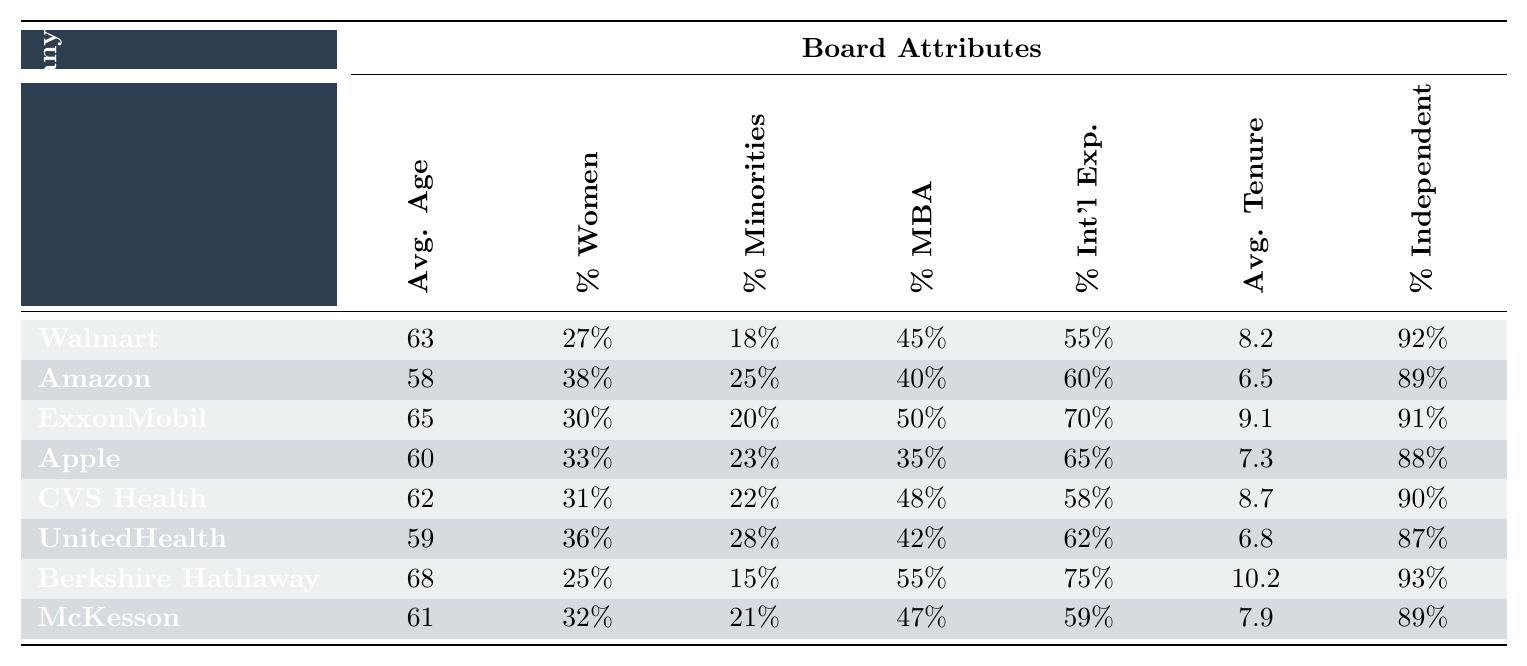What is the average age of the board members of Amazon? The table shows that the average age of Amazon board members is listed under the "Avg. Age" column as 58.
Answer: 58 Which company has the highest percentage of women on its board? By comparing the "% Women" values in the table, we can see that Amazon has the highest percentage at 38%.
Answer: 38% What is the average tenure of board members at Berkshire Hathaway? The average tenure is shown in the "Avg. Tenure" column for Berkshire Hathaway, which is 10.2 years.
Answer: 10.2 Is it true that CVS Health has more independent directors than McKesson? Looking at the "% Independent" column, CVS Health has 90% independent directors, while McKesson has 89%, indicating that CVS Health has more.
Answer: Yes What is the difference in average age between ExxonMobil and Walmart board members? The average age for ExxonMobil is 65, and for Walmart it is 63, so the difference is 65 - 63 = 2 years.
Answer: 2 If we sum the percentages of women across all companies, what is the total? The percentages of women are: 27 + 38 + 30 + 33 + 31 + 36 + 25 + 32 = 252%. Then, the total is 252%.
Answer: 252% What percentage of board members across all companies have international experience? By summing the percentages for "% Int'l Exp.": 55 + 60 + 70 + 65 + 58 + 62 + 75 + 59 =  474%. To find the average percentage of international experience, divide by the number of companies (8): 474 / 8 = 59.25%.
Answer: 59.25% Which company has the lowest percentage of racial/ethnic minorities on its board? By comparing the "% Minorities" column, we find that Berkshire Hathaway has the lowest percentage at 15%.
Answer: 15% What is the average age of the board members for companies with more than 30% women? The companies with more than 30% women are Amazon (58), ExxonMobil (65), Apple (60), and UnitedHealth (59). The average age = (58 + 65 + 60 + 59) / 4 = 60.5 years.
Answer: 60.5 Are there more board members with an MBA at ExxonMobil compared to CVS Health? Looking at the "% MBA" column, ExxonMobil has 50% and CVS Health has 48%, indicating that ExxonMobil has more board members with an MBA.
Answer: Yes What is the average tenure of board members in companies that have over 60% international experience? The companies with over 60% international experience are ExxonMobil (70), Berkshire Hathaway (75), and CVS Health (58). The average tenure = (9.1 + 10.2 + 8.7) / 3 = 9.33 years.
Answer: 9.33 